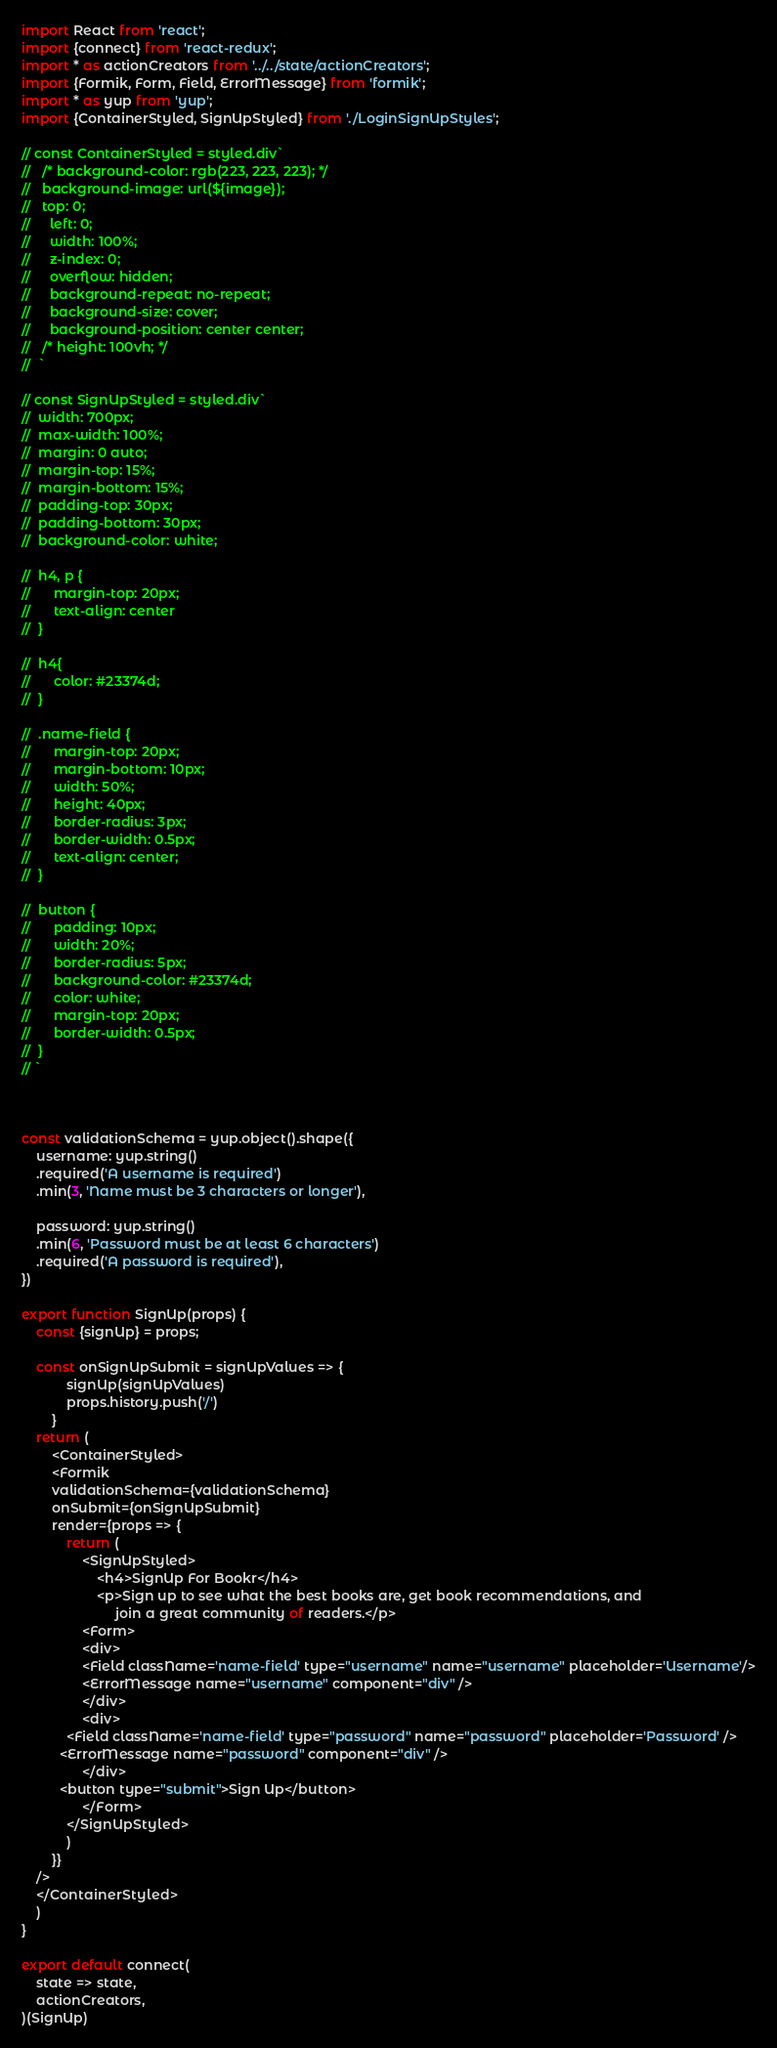Convert code to text. <code><loc_0><loc_0><loc_500><loc_500><_JavaScript_>import React from 'react';
import {connect} from 'react-redux';
import * as actionCreators from '../../state/actionCreators';
import {Formik, Form, Field, ErrorMessage} from 'formik';
import * as yup from 'yup';
import {ContainerStyled, SignUpStyled} from './LoginSignUpStyles';

// const ContainerStyled = styled.div`
// 	 /* background-color: rgb(223, 223, 223); */
// 	 background-image: url(${image});
// 	 top: 0;
//     left: 0;
//     width: 100%;
//     z-index: 0;
//     overflow: hidden;
//     background-repeat: no-repeat;
//     background-size: cover;
//     background-position: center center;
// 	 /* height: 100vh; */
// 	`

// const SignUpStyled = styled.div` 
// 	width: 700px;
// 	max-width: 100%;
// 	margin: 0 auto;
// 	margin-top: 15%;
// 	margin-bottom: 15%;
// 	padding-top: 30px;
// 	padding-bottom: 30px;
// 	background-color: white;

// 	h4, p {
// 		margin-top: 20px;
// 		text-align: center
// 	}

// 	h4{
// 		color: #23374d;
// 	}

// 	.name-field {
// 		margin-top: 20px;
// 		margin-bottom: 10px;
// 		width: 50%;
// 		height: 40px;
// 		border-radius: 3px;
// 		border-width: 0.5px;
// 		text-align: center;
// 	}

// 	button {
// 		padding: 10px;
// 		width: 20%;
// 		border-radius: 5px;
// 		background-color: #23374d;
// 		color: white;
// 		margin-top: 20px;
// 		border-width: 0.5px;
// 	}
// `



const validationSchema = yup.object().shape({
	username: yup.string()
	.required('A username is required')
	.min(3, 'Name must be 3 characters or longer'),

	password: yup.string()
	.min(6, 'Password must be at least 6 characters')
	.required('A password is required'),
})

export function SignUp(props) {
	const {signUp} = props;

	const onSignUpSubmit = signUpValues => {
			signUp(signUpValues)
			props.history.push('/')
		}
	return (
		<ContainerStyled>
		<Formik 
		validationSchema={validationSchema}
		onSubmit={onSignUpSubmit}
		render={props => {
			return (
				<SignUpStyled>
					<h4>SignUp For Bookr</h4>
					<p>Sign up to see what the best books are, get book recommendations, and
						 join a great community of readers.</p>
				<Form>
				<div>
				<Field className='name-field' type="username" name="username" placeholder='Username'/>
          		<ErrorMessage name="username" component="div" />
				</div>
				<div>
          	<Field className='name-field' type="password" name="password" placeholder='Password' />
          <ErrorMessage name="password" component="div" />
				</div>
          <button type="submit">Sign Up</button>
				</Form>
			</SignUpStyled>
			)
		}}
	/>
	</ContainerStyled>
	)
}

export default connect(
	state => state,
	actionCreators,
)(SignUp)</code> 